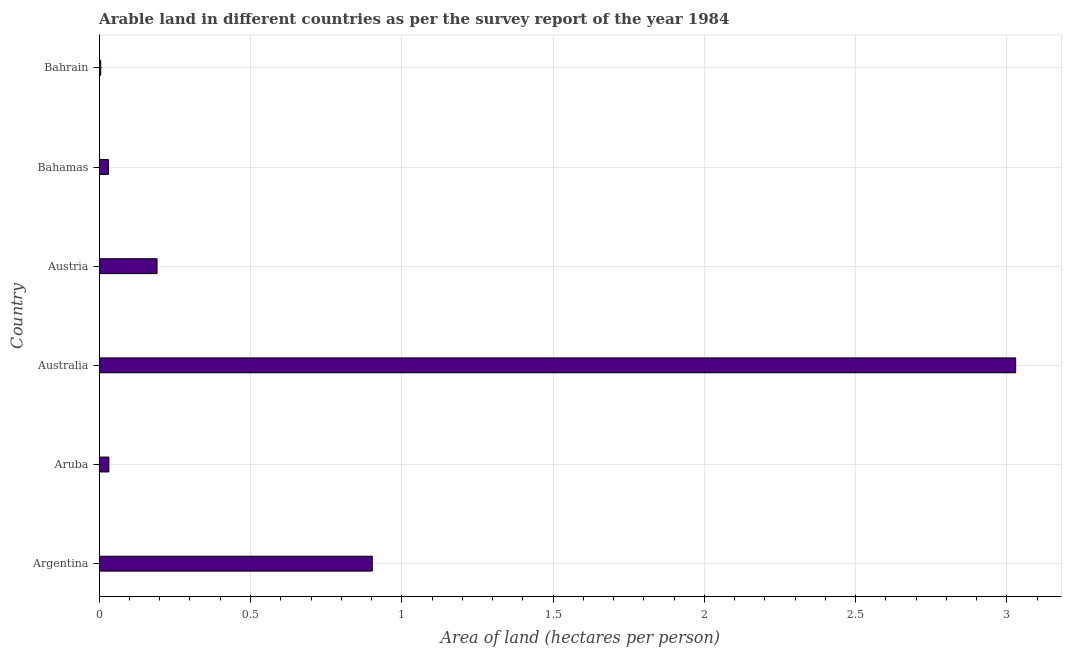Does the graph contain any zero values?
Ensure brevity in your answer.  No. Does the graph contain grids?
Keep it short and to the point. Yes. What is the title of the graph?
Your answer should be very brief. Arable land in different countries as per the survey report of the year 1984. What is the label or title of the X-axis?
Your answer should be very brief. Area of land (hectares per person). What is the area of arable land in Bahrain?
Offer a very short reply. 0. Across all countries, what is the maximum area of arable land?
Offer a terse response. 3.03. Across all countries, what is the minimum area of arable land?
Your response must be concise. 0. In which country was the area of arable land maximum?
Your answer should be very brief. Australia. In which country was the area of arable land minimum?
Your response must be concise. Bahrain. What is the sum of the area of arable land?
Give a very brief answer. 4.19. What is the average area of arable land per country?
Offer a terse response. 0.7. What is the median area of arable land?
Provide a succinct answer. 0.11. In how many countries, is the area of arable land greater than 1.3 hectares per person?
Your answer should be compact. 1. What is the ratio of the area of arable land in Argentina to that in Austria?
Provide a short and direct response. 4.72. What is the difference between the highest and the second highest area of arable land?
Your answer should be very brief. 2.13. What is the difference between the highest and the lowest area of arable land?
Your answer should be very brief. 3.02. In how many countries, is the area of arable land greater than the average area of arable land taken over all countries?
Your response must be concise. 2. How many bars are there?
Your answer should be very brief. 6. Are all the bars in the graph horizontal?
Ensure brevity in your answer.  Yes. What is the difference between two consecutive major ticks on the X-axis?
Your answer should be very brief. 0.5. Are the values on the major ticks of X-axis written in scientific E-notation?
Offer a terse response. No. What is the Area of land (hectares per person) in Argentina?
Provide a short and direct response. 0.9. What is the Area of land (hectares per person) of Aruba?
Provide a short and direct response. 0.03. What is the Area of land (hectares per person) of Australia?
Ensure brevity in your answer.  3.03. What is the Area of land (hectares per person) in Austria?
Provide a succinct answer. 0.19. What is the Area of land (hectares per person) of Bahamas?
Ensure brevity in your answer.  0.03. What is the Area of land (hectares per person) of Bahrain?
Keep it short and to the point. 0. What is the difference between the Area of land (hectares per person) in Argentina and Aruba?
Make the answer very short. 0.87. What is the difference between the Area of land (hectares per person) in Argentina and Australia?
Make the answer very short. -2.13. What is the difference between the Area of land (hectares per person) in Argentina and Austria?
Offer a terse response. 0.71. What is the difference between the Area of land (hectares per person) in Argentina and Bahamas?
Ensure brevity in your answer.  0.87. What is the difference between the Area of land (hectares per person) in Argentina and Bahrain?
Your answer should be very brief. 0.9. What is the difference between the Area of land (hectares per person) in Aruba and Australia?
Provide a succinct answer. -3. What is the difference between the Area of land (hectares per person) in Aruba and Austria?
Give a very brief answer. -0.16. What is the difference between the Area of land (hectares per person) in Aruba and Bahamas?
Offer a very short reply. 0. What is the difference between the Area of land (hectares per person) in Aruba and Bahrain?
Your answer should be very brief. 0.03. What is the difference between the Area of land (hectares per person) in Australia and Austria?
Provide a succinct answer. 2.84. What is the difference between the Area of land (hectares per person) in Australia and Bahamas?
Give a very brief answer. 3. What is the difference between the Area of land (hectares per person) in Australia and Bahrain?
Provide a succinct answer. 3.02. What is the difference between the Area of land (hectares per person) in Austria and Bahamas?
Keep it short and to the point. 0.16. What is the difference between the Area of land (hectares per person) in Austria and Bahrain?
Offer a very short reply. 0.19. What is the difference between the Area of land (hectares per person) in Bahamas and Bahrain?
Your response must be concise. 0.03. What is the ratio of the Area of land (hectares per person) in Argentina to that in Aruba?
Your response must be concise. 28.35. What is the ratio of the Area of land (hectares per person) in Argentina to that in Australia?
Provide a succinct answer. 0.3. What is the ratio of the Area of land (hectares per person) in Argentina to that in Austria?
Provide a short and direct response. 4.72. What is the ratio of the Area of land (hectares per person) in Argentina to that in Bahamas?
Make the answer very short. 29.65. What is the ratio of the Area of land (hectares per person) in Argentina to that in Bahrain?
Ensure brevity in your answer.  183.74. What is the ratio of the Area of land (hectares per person) in Aruba to that in Australia?
Provide a short and direct response. 0.01. What is the ratio of the Area of land (hectares per person) in Aruba to that in Austria?
Provide a short and direct response. 0.17. What is the ratio of the Area of land (hectares per person) in Aruba to that in Bahamas?
Make the answer very short. 1.05. What is the ratio of the Area of land (hectares per person) in Aruba to that in Bahrain?
Provide a short and direct response. 6.48. What is the ratio of the Area of land (hectares per person) in Australia to that in Austria?
Keep it short and to the point. 15.85. What is the ratio of the Area of land (hectares per person) in Australia to that in Bahamas?
Ensure brevity in your answer.  99.53. What is the ratio of the Area of land (hectares per person) in Australia to that in Bahrain?
Keep it short and to the point. 616.7. What is the ratio of the Area of land (hectares per person) in Austria to that in Bahamas?
Your response must be concise. 6.28. What is the ratio of the Area of land (hectares per person) in Austria to that in Bahrain?
Your response must be concise. 38.91. What is the ratio of the Area of land (hectares per person) in Bahamas to that in Bahrain?
Provide a succinct answer. 6.2. 